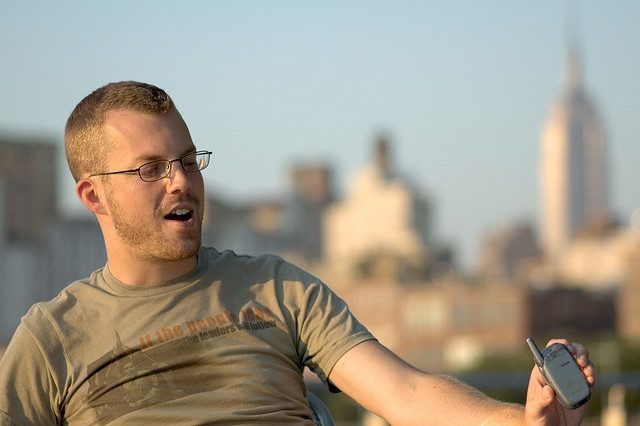Describe the objects in this image and their specific colors. I can see people in lightblue, gray, and tan tones and cell phone in lightblue, gray, and black tones in this image. 